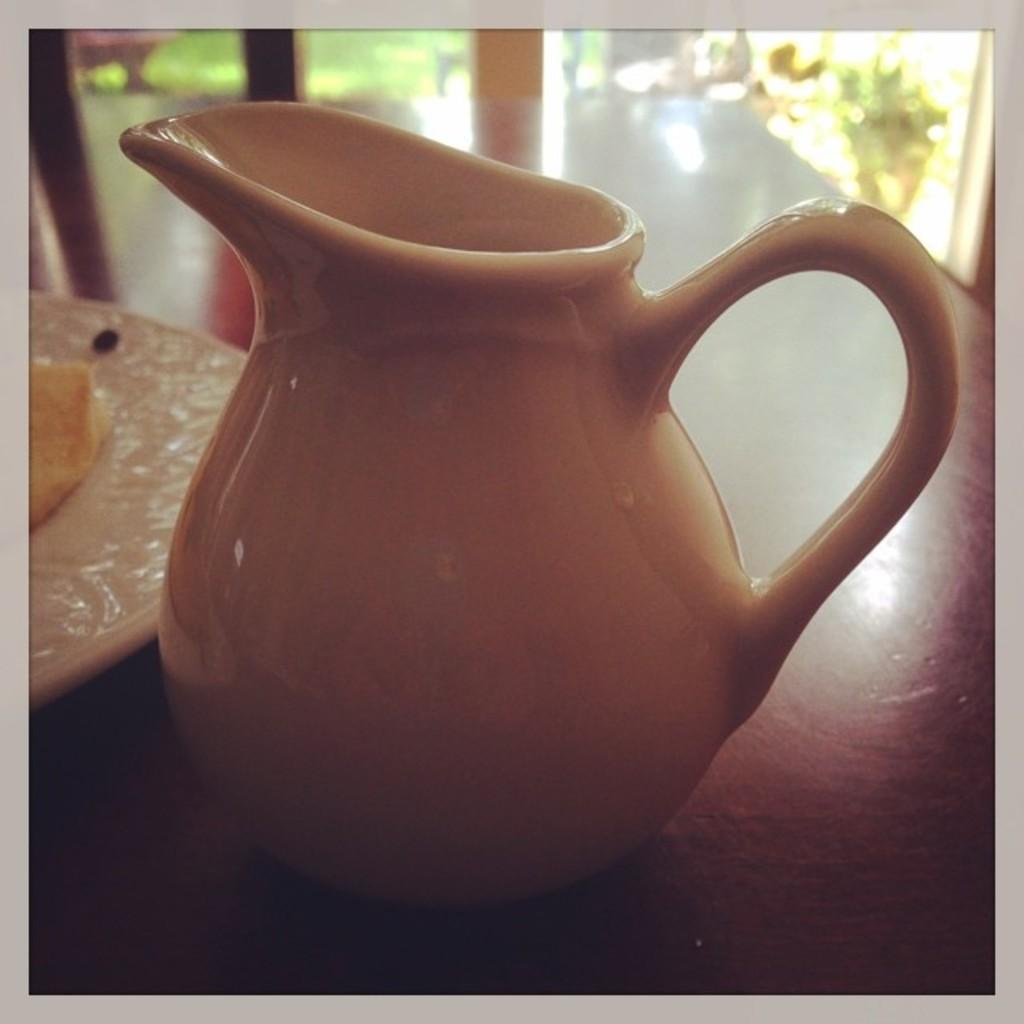What is on the table in the image? There is a jug, a plate, bread, and seeds on the table. What can be seen beside the table? There is a chair and a window beside the table. What is visible through the window? Plants and grass are visible through the window. What team is the education system in the image associated with? There is no reference to an education system or a team in the image. 